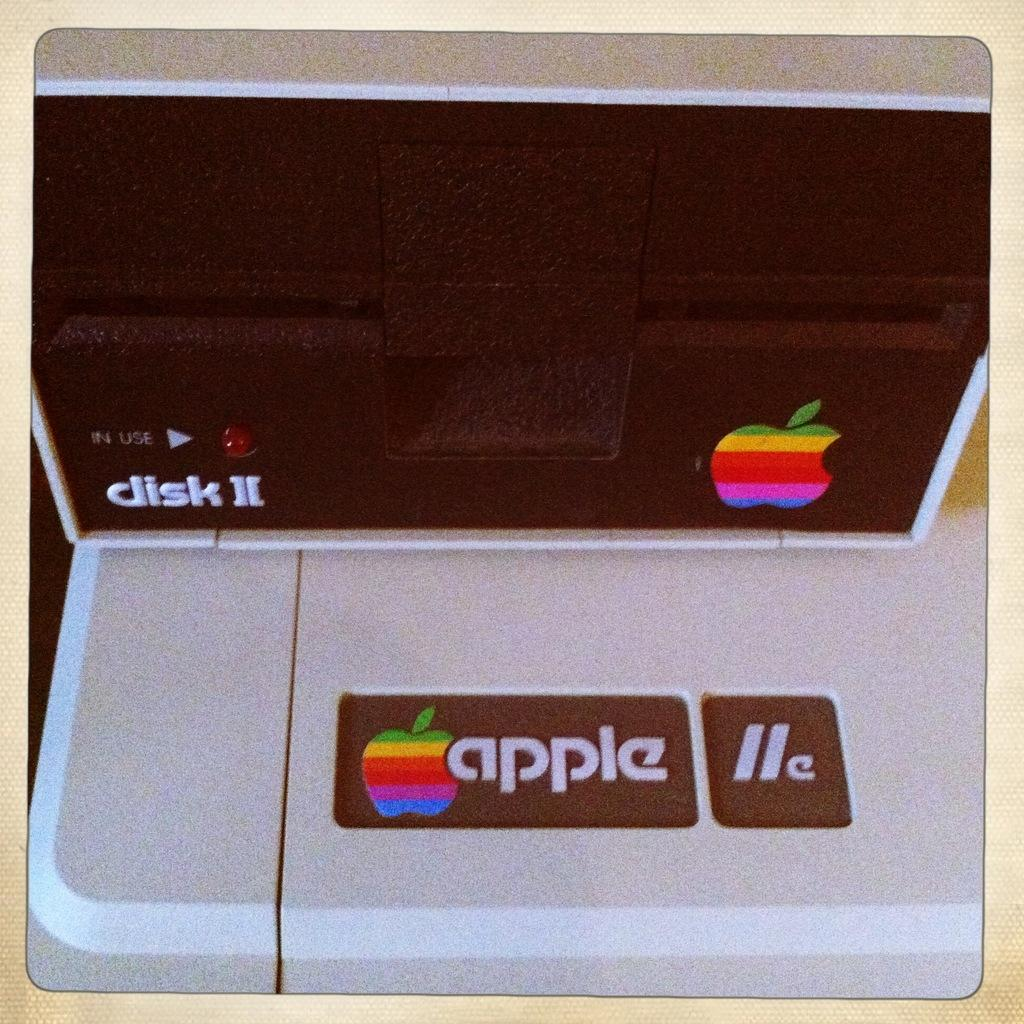<image>
Summarize the visual content of the image. An Apple IIe disk drive has a multi colored apple as its logo. 